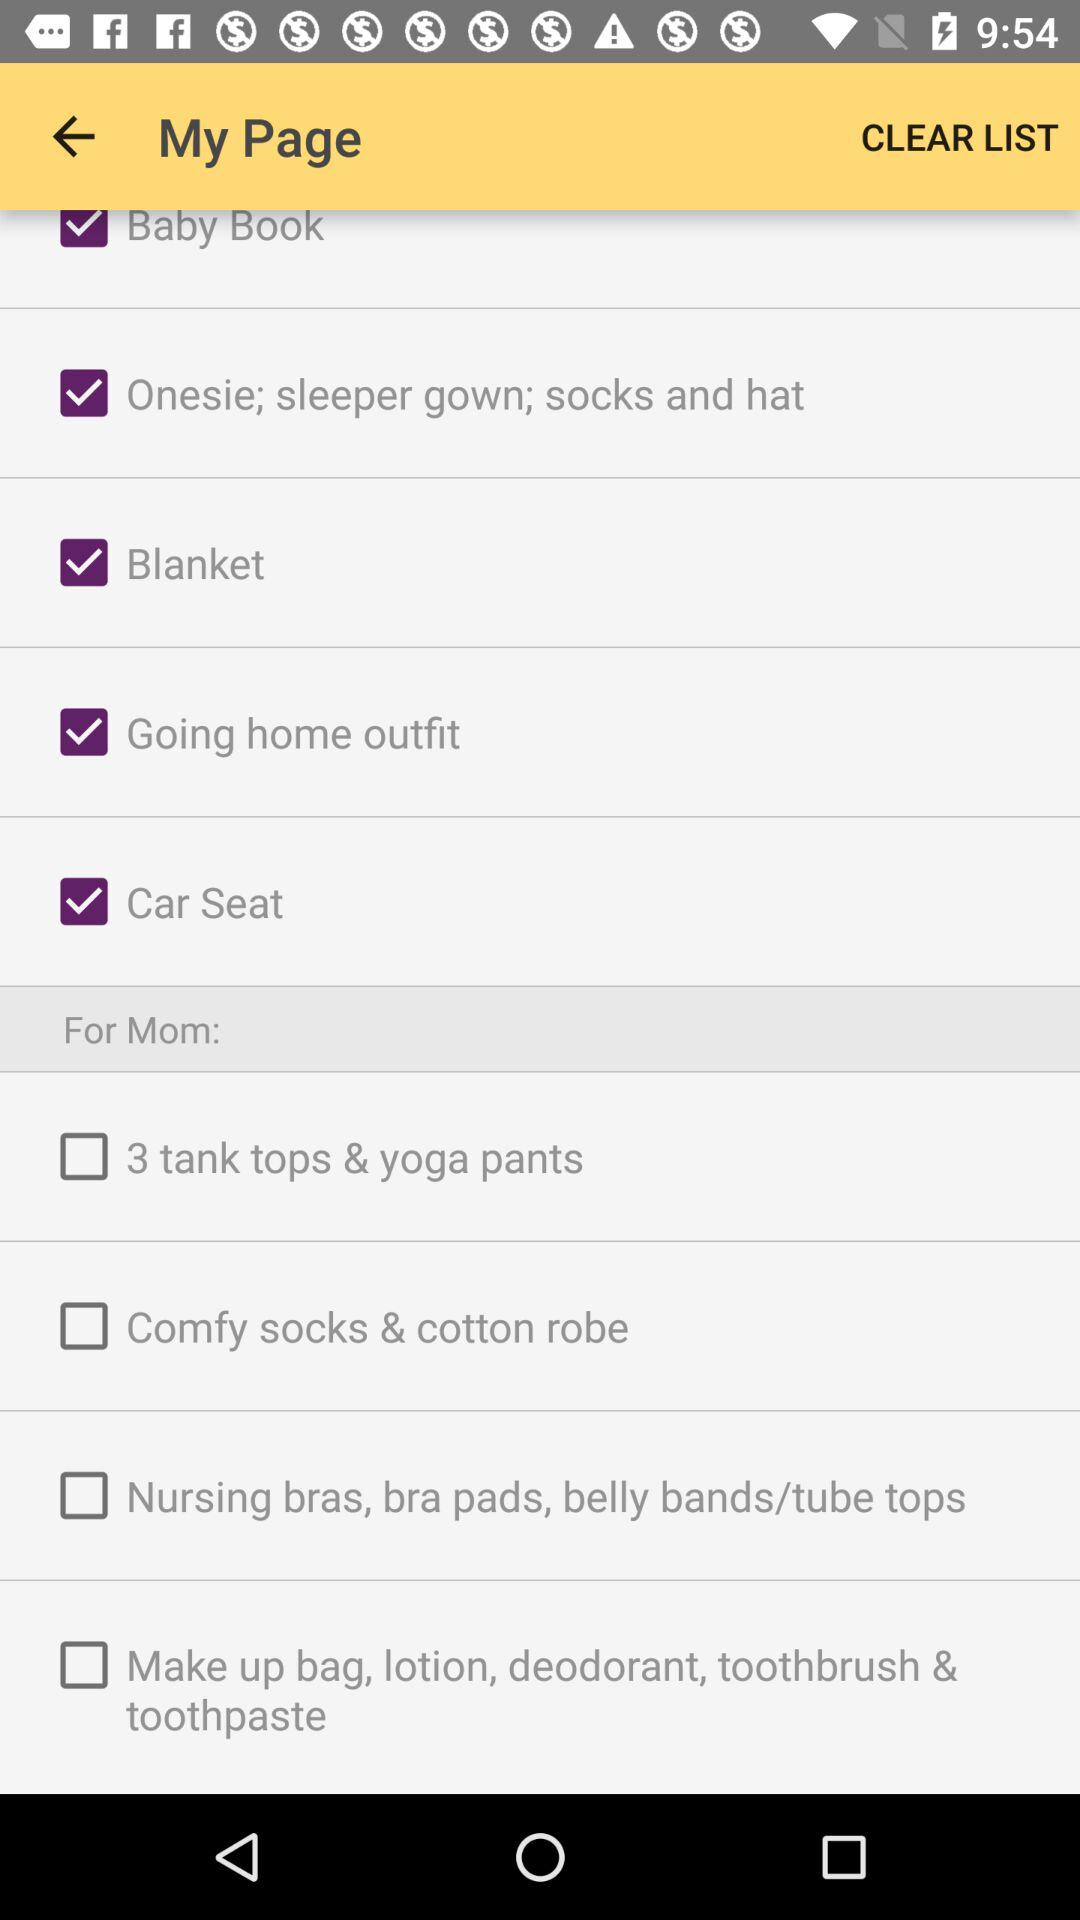Is "For Mom:" on or off?
When the provided information is insufficient, respond with <no answer>. <no answer> 